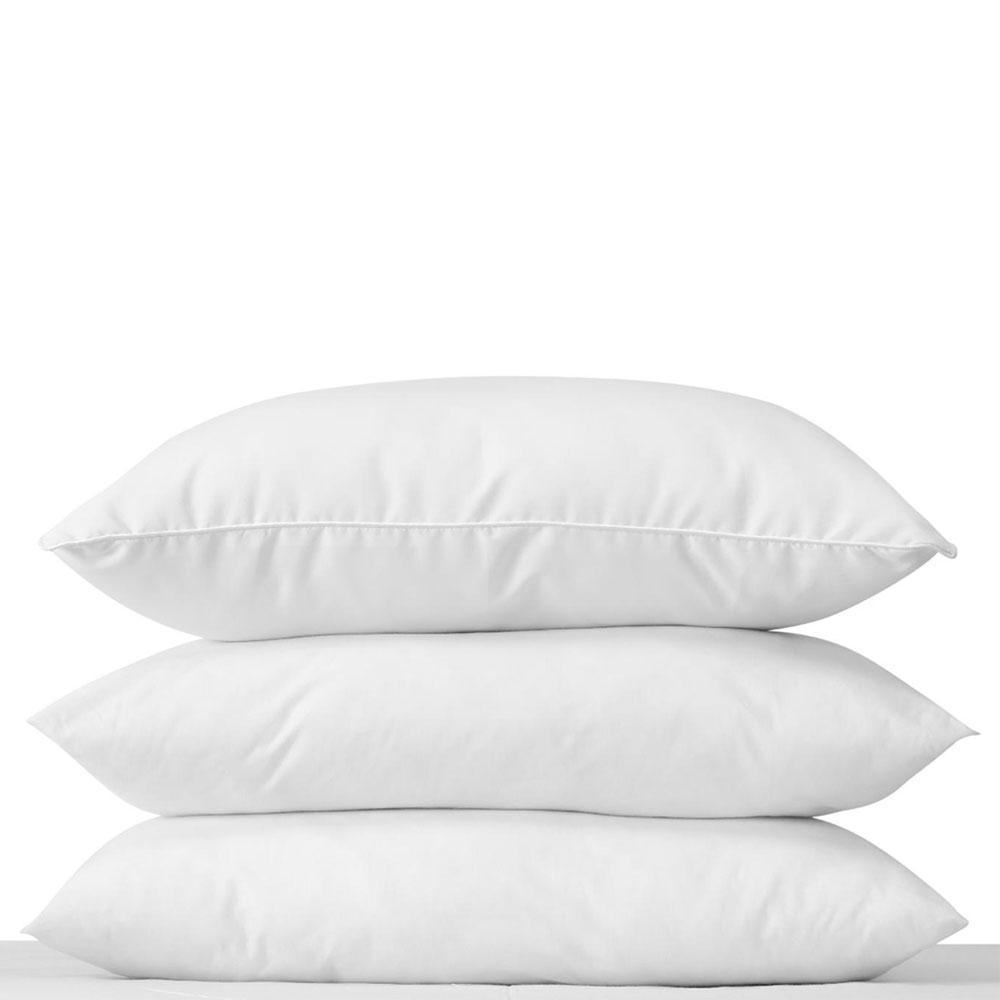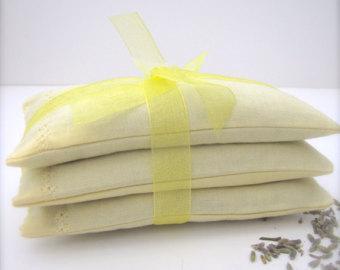The first image is the image on the left, the second image is the image on the right. Evaluate the accuracy of this statement regarding the images: "The right image contains three pillows stacked on top of each other.". Is it true? Answer yes or no. Yes. The first image is the image on the left, the second image is the image on the right. Considering the images on both sides, is "The lefthand image contains a vertical stack of three solid-white pillows." valid? Answer yes or no. Yes. 